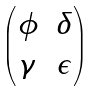<formula> <loc_0><loc_0><loc_500><loc_500>\begin{pmatrix} \phi & \delta \\ \gamma & \epsilon \end{pmatrix}</formula> 